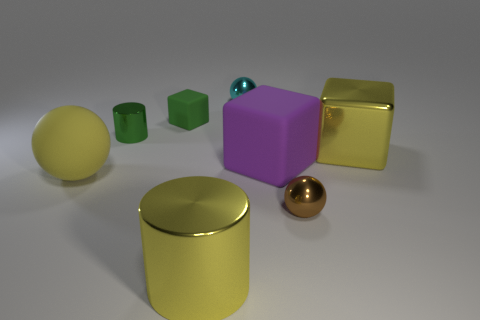Add 1 brown things. How many objects exist? 9 Subtract all blocks. How many objects are left? 5 Add 8 large metal blocks. How many large metal blocks exist? 9 Subtract 0 purple cylinders. How many objects are left? 8 Subtract all small yellow matte cubes. Subtract all small green cylinders. How many objects are left? 7 Add 3 shiny cylinders. How many shiny cylinders are left? 5 